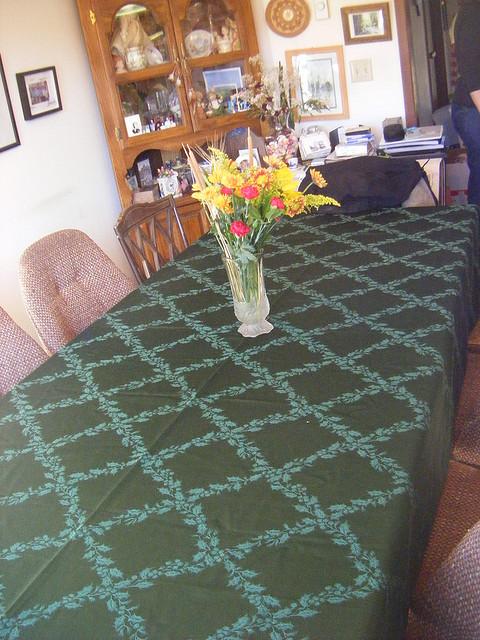How many shades of green in the tablecloth?
Give a very brief answer. 2. Is there a clock on the wall?
Write a very short answer. Yes. Is this a dining table?
Be succinct. Yes. 